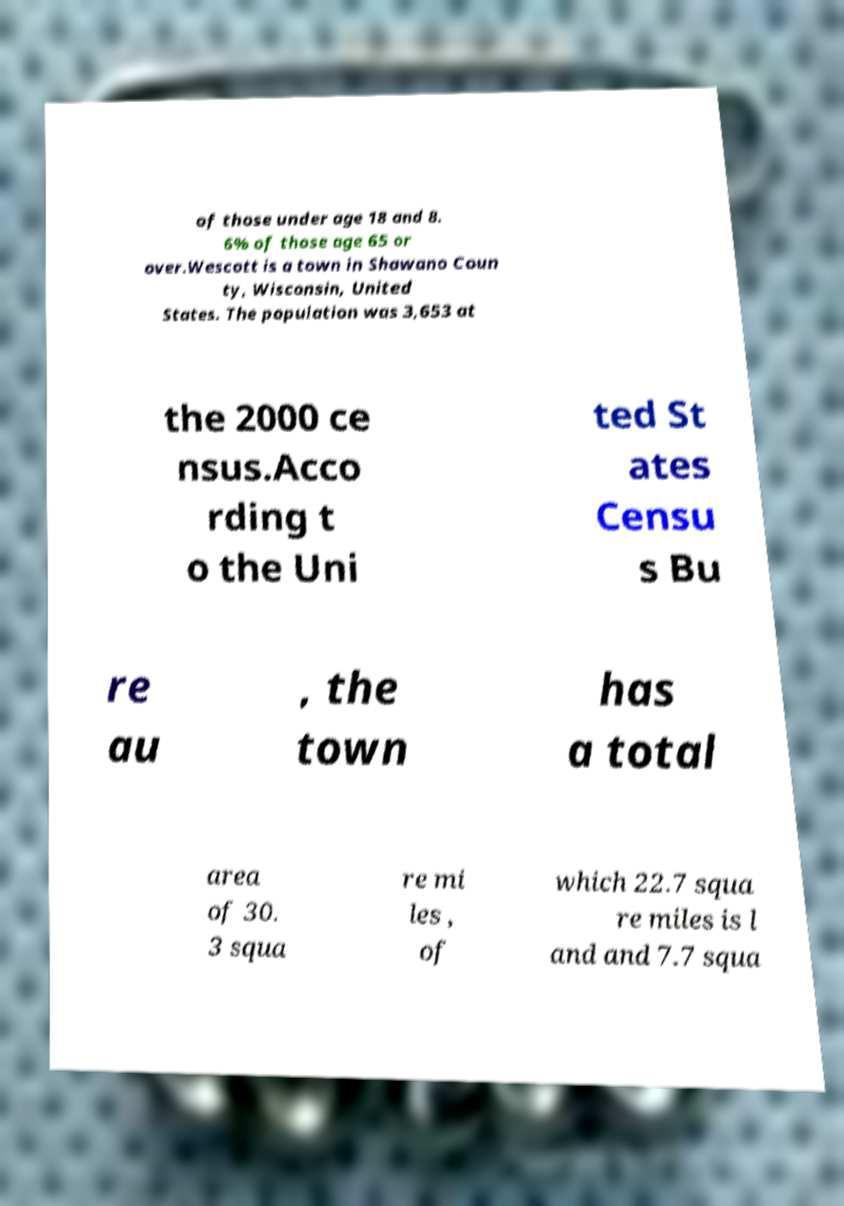Can you read and provide the text displayed in the image?This photo seems to have some interesting text. Can you extract and type it out for me? of those under age 18 and 8. 6% of those age 65 or over.Wescott is a town in Shawano Coun ty, Wisconsin, United States. The population was 3,653 at the 2000 ce nsus.Acco rding t o the Uni ted St ates Censu s Bu re au , the town has a total area of 30. 3 squa re mi les , of which 22.7 squa re miles is l and and 7.7 squa 